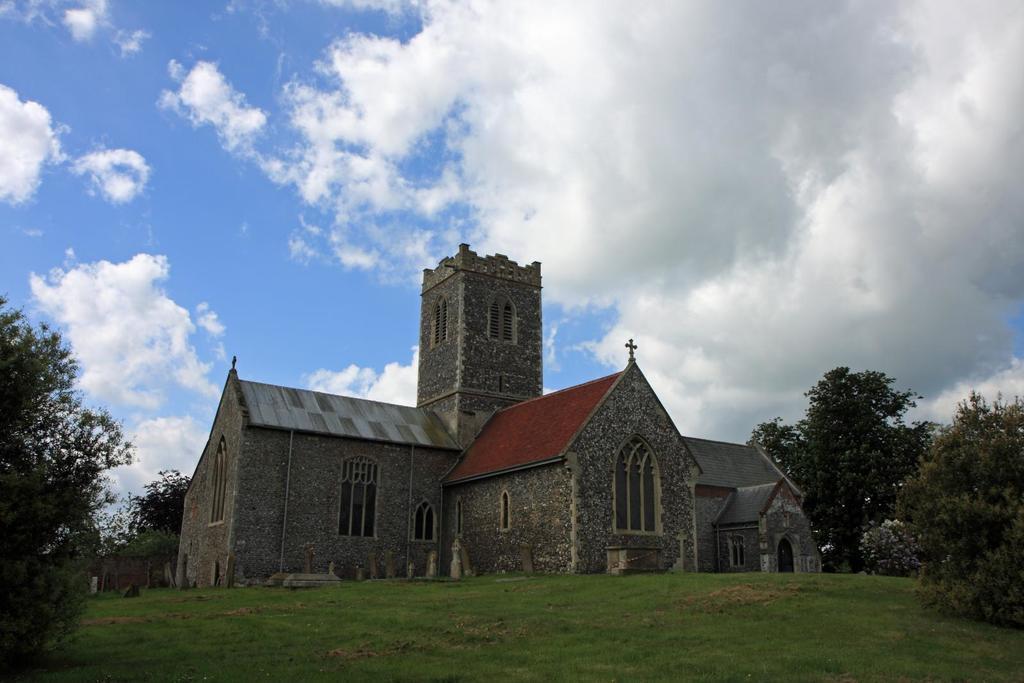Describe this image in one or two sentences. In the center of the image there is a building. At the bottom there is grass and trees. In the background we can see trees, sky and clouds. 